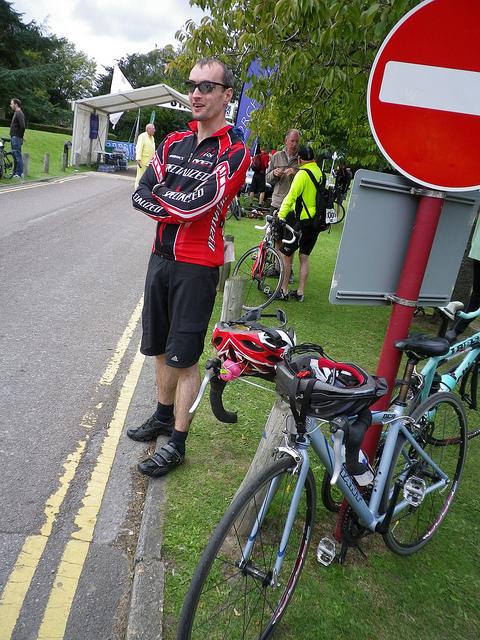Does anyone have on a yellow shirt?
Write a very short answer. Yes. What vehicles are in the picture?
Keep it brief. Bicycles. Do the shirt and sign match?
Answer briefly. Yes. What does the street sign mean?
Keep it brief. Do not enter. 